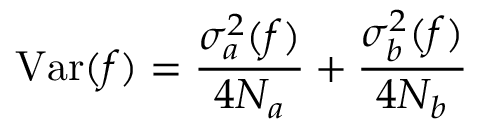Convert formula to latex. <formula><loc_0><loc_0><loc_500><loc_500>V a r ( f ) = { \frac { \sigma _ { a } ^ { 2 } ( f ) } { 4 N _ { a } } } + { \frac { \sigma _ { b } ^ { 2 } ( f ) } { 4 N _ { b } } }</formula> 